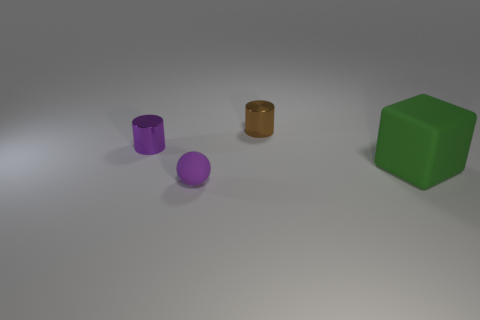There is a small brown object that is the same shape as the purple metallic object; what is it made of?
Your answer should be compact. Metal. The cube that is the same material as the tiny sphere is what size?
Offer a very short reply. Large. Is the number of tiny purple cylinders less than the number of tiny purple objects?
Your response must be concise. Yes. There is a thing that is the same color as the sphere; what shape is it?
Your answer should be compact. Cylinder. What number of big rubber objects are in front of the tiny brown thing?
Ensure brevity in your answer.  1. Is the purple rubber thing the same shape as the green object?
Your answer should be compact. No. What number of things are both behind the small rubber sphere and left of the large green cube?
Offer a very short reply. 2. What number of objects are large cyan metallic objects or objects that are in front of the brown cylinder?
Provide a succinct answer. 3. Is the number of purple rubber spheres greater than the number of tiny red shiny blocks?
Offer a very short reply. Yes. There is a matte thing that is right of the tiny brown cylinder; what is its shape?
Make the answer very short. Cube. 